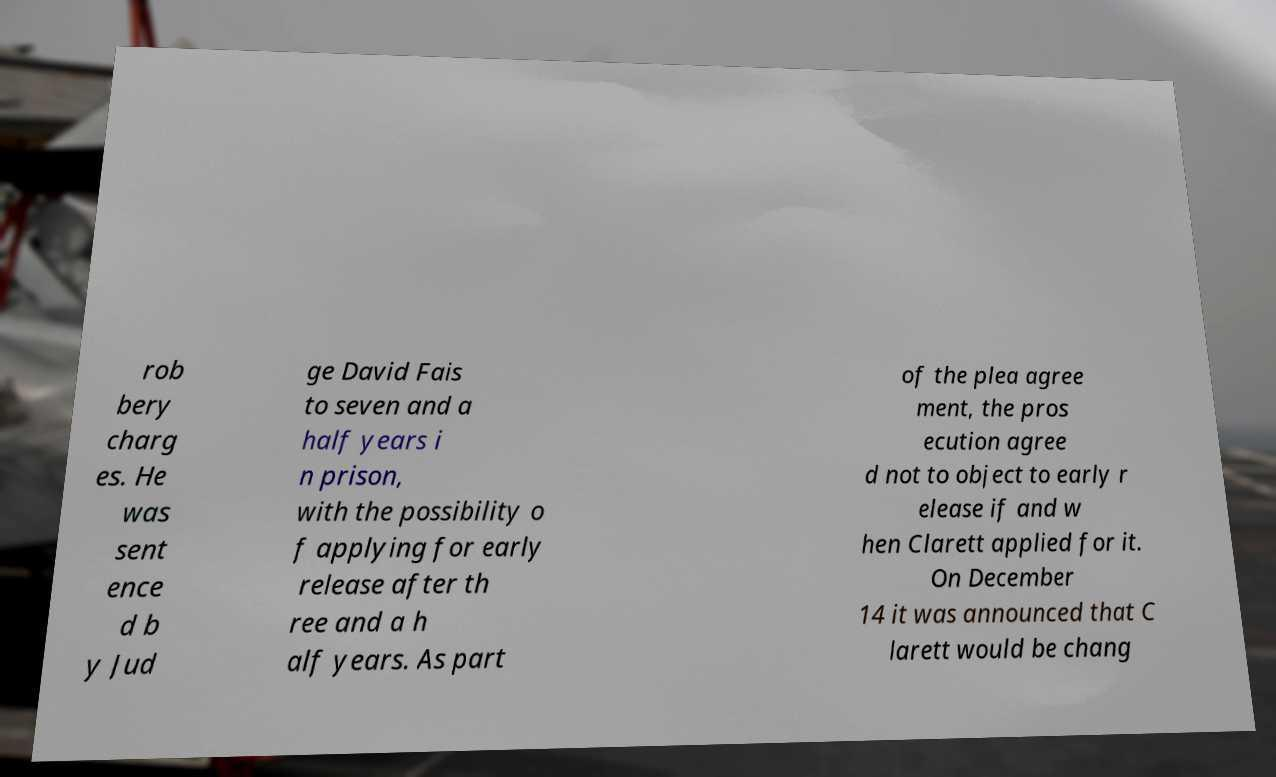There's text embedded in this image that I need extracted. Can you transcribe it verbatim? rob bery charg es. He was sent ence d b y Jud ge David Fais to seven and a half years i n prison, with the possibility o f applying for early release after th ree and a h alf years. As part of the plea agree ment, the pros ecution agree d not to object to early r elease if and w hen Clarett applied for it. On December 14 it was announced that C larett would be chang 